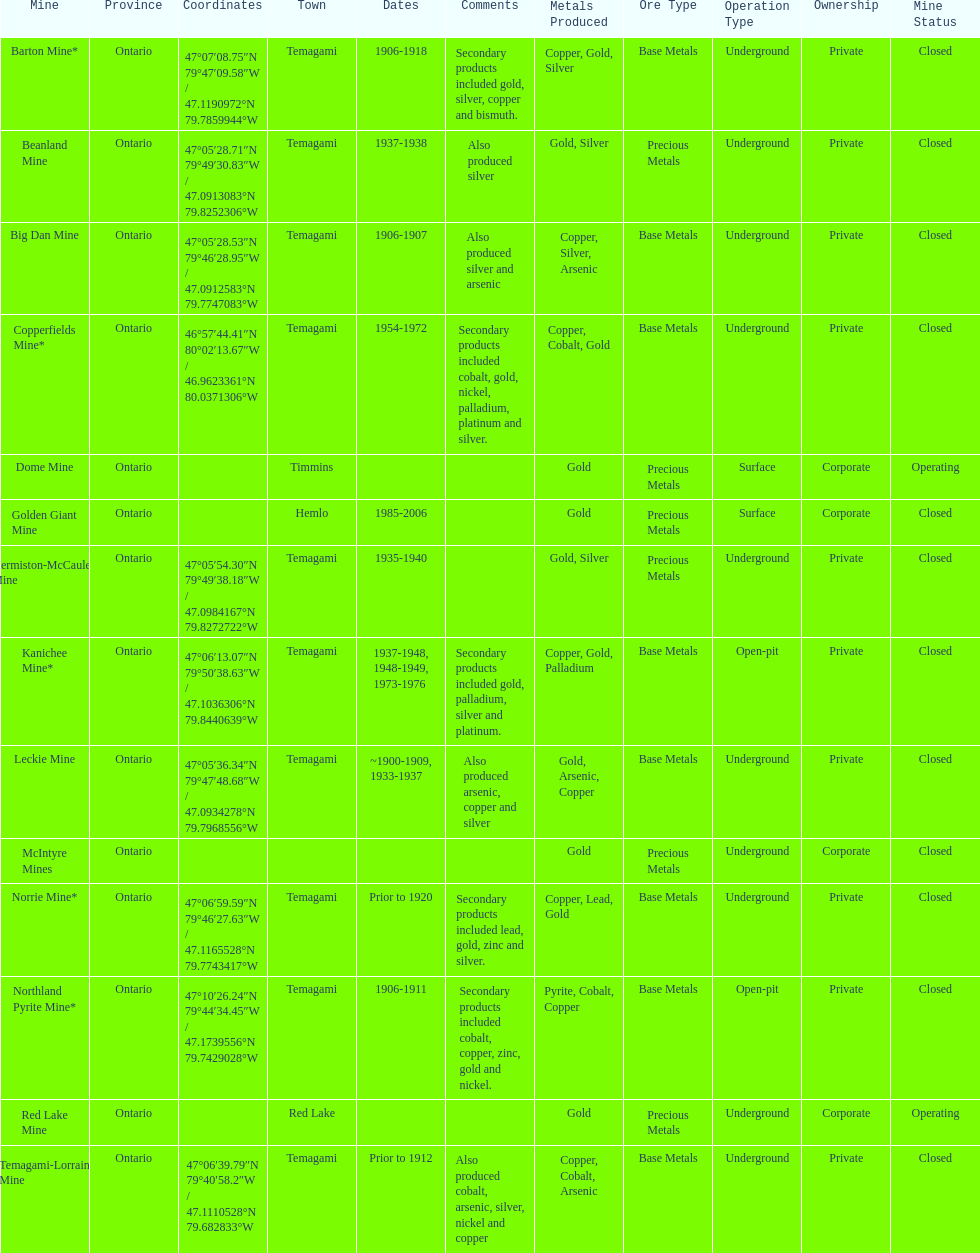Can you provide the name of a gold mine that has been functioning for 10 years or more? Barton Mine. Could you help me parse every detail presented in this table? {'header': ['Mine', 'Province', 'Coordinates', 'Town', 'Dates', 'Comments', 'Metals Produced', 'Ore Type', 'Operation Type', 'Ownership', 'Mine Status'], 'rows': [['Barton Mine*', 'Ontario', '47°07′08.75″N 79°47′09.58″W\ufeff / \ufeff47.1190972°N 79.7859944°W', 'Temagami', '1906-1918', 'Secondary products included gold, silver, copper and bismuth.', 'Copper, Gold, Silver', 'Base Metals', 'Underground', 'Private', 'Closed'], ['Beanland Mine', 'Ontario', '47°05′28.71″N 79°49′30.83″W\ufeff / \ufeff47.0913083°N 79.8252306°W', 'Temagami', '1937-1938', 'Also produced silver', 'Gold, Silver', 'Precious Metals', 'Underground', 'Private', 'Closed'], ['Big Dan Mine', 'Ontario', '47°05′28.53″N 79°46′28.95″W\ufeff / \ufeff47.0912583°N 79.7747083°W', 'Temagami', '1906-1907', 'Also produced silver and arsenic', 'Copper, Silver, Arsenic', 'Base Metals', 'Underground', 'Private', 'Closed'], ['Copperfields Mine*', 'Ontario', '46°57′44.41″N 80°02′13.67″W\ufeff / \ufeff46.9623361°N 80.0371306°W', 'Temagami', '1954-1972', 'Secondary products included cobalt, gold, nickel, palladium, platinum and silver.', 'Copper, Cobalt, Gold', 'Base Metals', 'Underground', 'Private', 'Closed'], ['Dome Mine', 'Ontario', '', 'Timmins', '', '', 'Gold', 'Precious Metals', 'Surface', 'Corporate', 'Operating'], ['Golden Giant Mine', 'Ontario', '', 'Hemlo', '1985-2006', '', 'Gold', 'Precious Metals', 'Surface', 'Corporate', 'Closed'], ['Hermiston-McCauley Mine', 'Ontario', '47°05′54.30″N 79°49′38.18″W\ufeff / \ufeff47.0984167°N 79.8272722°W', 'Temagami', '1935-1940', '', 'Gold, Silver', 'Precious Metals', 'Underground', 'Private', 'Closed'], ['Kanichee Mine*', 'Ontario', '47°06′13.07″N 79°50′38.63″W\ufeff / \ufeff47.1036306°N 79.8440639°W', 'Temagami', '1937-1948, 1948-1949, 1973-1976', 'Secondary products included gold, palladium, silver and platinum.', 'Copper, Gold, Palladium', 'Base Metals', 'Open-pit', 'Private', 'Closed'], ['Leckie Mine', 'Ontario', '47°05′36.34″N 79°47′48.68″W\ufeff / \ufeff47.0934278°N 79.7968556°W', 'Temagami', '~1900-1909, 1933-1937', 'Also produced arsenic, copper and silver', 'Gold, Arsenic, Copper', 'Base Metals', 'Underground', 'Private', 'Closed'], ['McIntyre Mines', 'Ontario', '', '', '', '', 'Gold', 'Precious Metals', 'Underground', 'Corporate', 'Closed'], ['Norrie Mine*', 'Ontario', '47°06′59.59″N 79°46′27.63″W\ufeff / \ufeff47.1165528°N 79.7743417°W', 'Temagami', 'Prior to 1920', 'Secondary products included lead, gold, zinc and silver.', 'Copper, Lead, Gold', 'Base Metals', 'Underground', 'Private', 'Closed'], ['Northland Pyrite Mine*', 'Ontario', '47°10′26.24″N 79°44′34.45″W\ufeff / \ufeff47.1739556°N 79.7429028°W', 'Temagami', '1906-1911', 'Secondary products included cobalt, copper, zinc, gold and nickel.', 'Pyrite, Cobalt, Copper', 'Base Metals', 'Open-pit', 'Private', 'Closed'], ['Red Lake Mine', 'Ontario', '', 'Red Lake', '', '', 'Gold', 'Precious Metals', 'Underground', 'Corporate', 'Operating'], ['Temagami-Lorrain Mine', 'Ontario', '47°06′39.79″N 79°40′58.2″W\ufeff / \ufeff47.1110528°N 79.682833°W', 'Temagami', 'Prior to 1912', 'Also produced cobalt, arsenic, silver, nickel and copper', 'Copper, Cobalt, Arsenic', 'Base Metals', 'Underground', 'Private', 'Closed']]} 